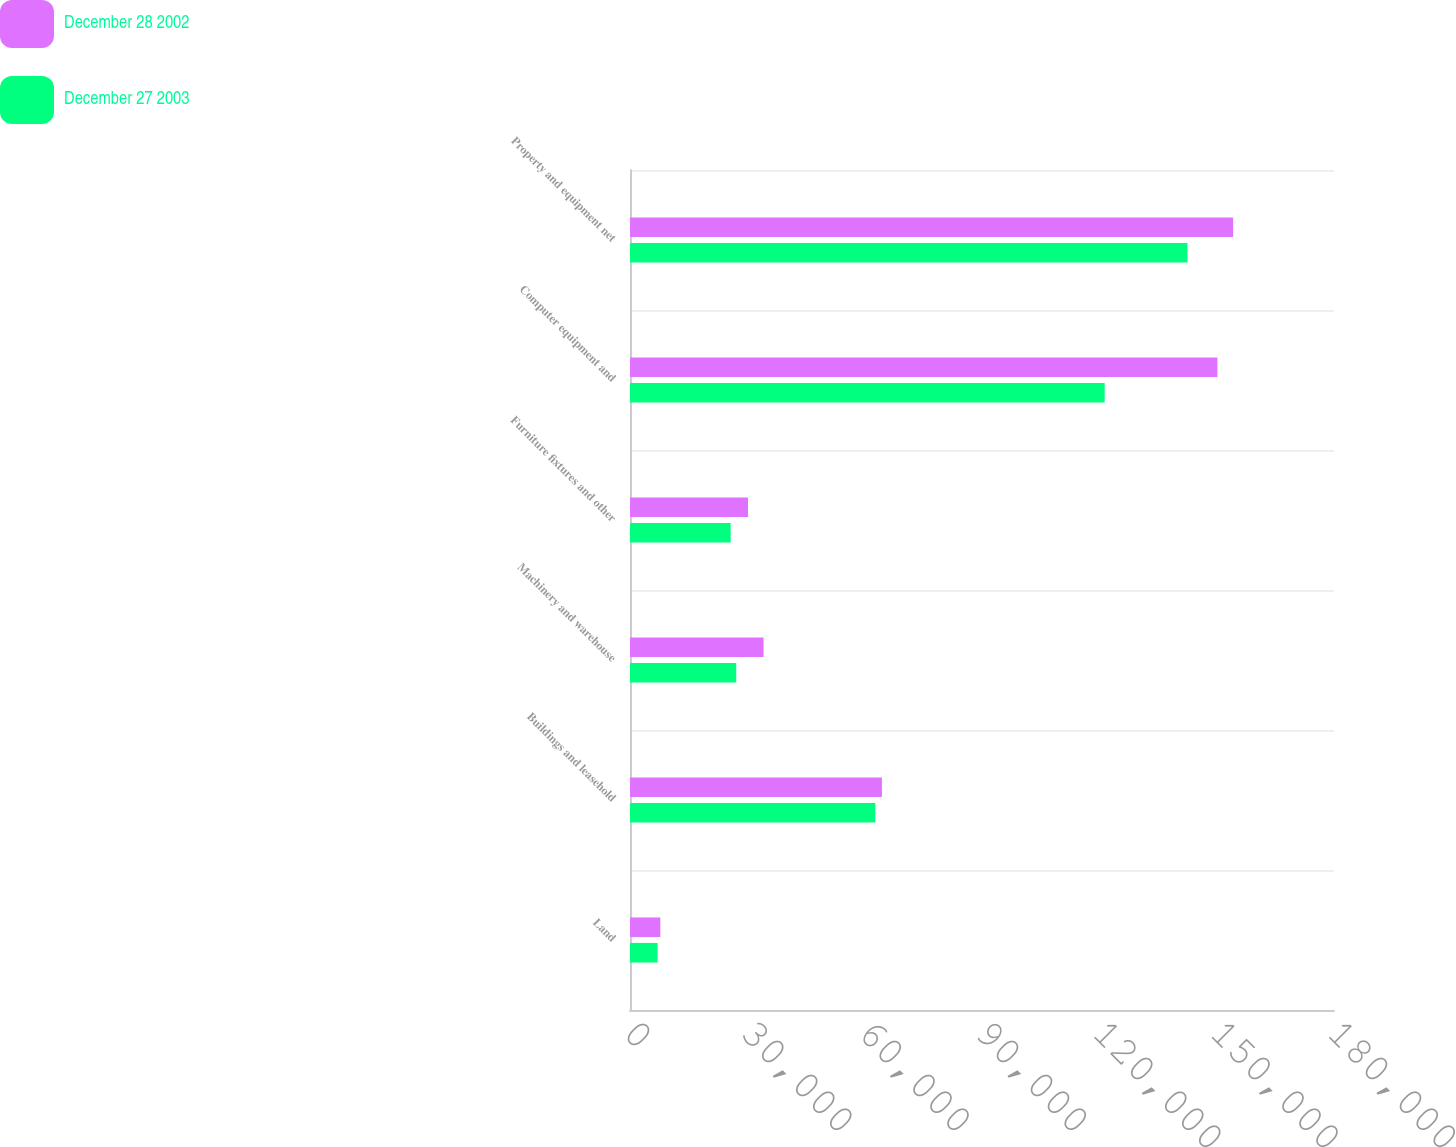Convert chart. <chart><loc_0><loc_0><loc_500><loc_500><stacked_bar_chart><ecel><fcel>Land<fcel>Buildings and leasehold<fcel>Machinery and warehouse<fcel>Furniture fixtures and other<fcel>Computer equipment and<fcel>Property and equipment net<nl><fcel>December 28 2002<fcel>7754<fcel>64410<fcel>34148<fcel>30176<fcel>150193<fcel>154205<nl><fcel>December 27 2003<fcel>7061<fcel>62724<fcel>27165<fcel>25737<fcel>121364<fcel>142532<nl></chart> 